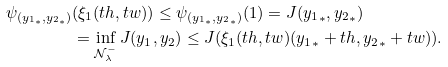<formula> <loc_0><loc_0><loc_500><loc_500>\psi _ { ( { y _ { 1 } } _ { * } , { y _ { 2 } } _ { * } ) } & ( \xi _ { 1 } ( t h , t w ) ) \leq \psi _ { ( { y _ { 1 } } _ { * } , { y _ { 2 } } _ { * } ) } ( 1 ) = J ( { y _ { 1 } } _ { * } , { y _ { 2 } } _ { * } ) \\ & = \inf _ { \mathcal { N } _ { \lambda } ^ { - } } J ( y _ { 1 } , y _ { 2 } ) \leq J ( \xi _ { 1 } ( t h , t w ) ( { y _ { 1 } } _ { * } + t h , { y _ { 2 } } _ { * } + t w ) ) . \\</formula> 